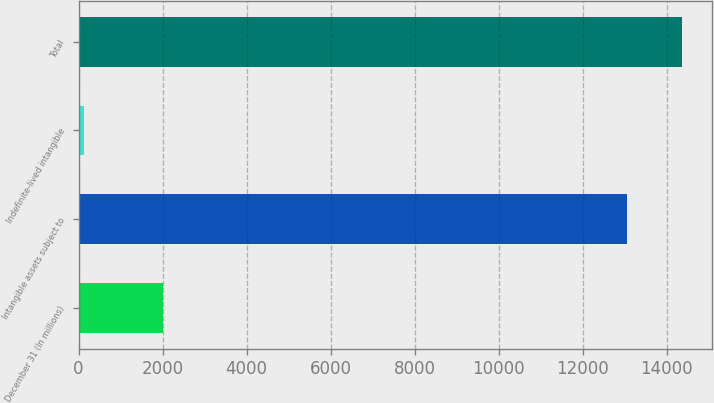Convert chart. <chart><loc_0><loc_0><loc_500><loc_500><bar_chart><fcel>December 31 (In millions)<fcel>Intangible assets subject to<fcel>Indefinite-lived intangible<fcel>Total<nl><fcel>2014<fcel>13052<fcel>130<fcel>14357.2<nl></chart> 